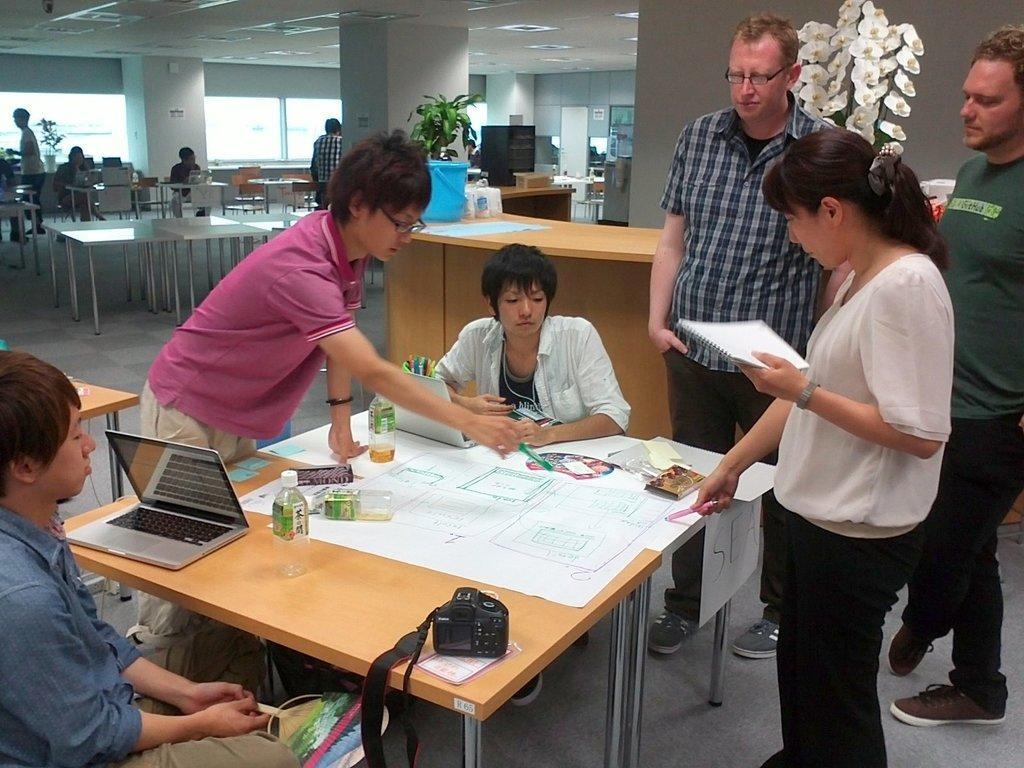Describe this image in one or two sentences. In this image there are group of persons standing and sitting in the room and there is a chart laptop and camera on the table and at the background there are persons sitting and standing. 